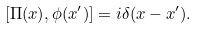<formula> <loc_0><loc_0><loc_500><loc_500>[ \Pi ( x ) , \phi ( x ^ { \prime } ) ] = i \delta ( x - x ^ { \prime } ) .</formula> 